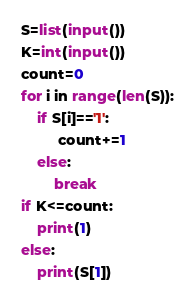Convert code to text. <code><loc_0><loc_0><loc_500><loc_500><_Python_>S=list(input())
K=int(input())
count=0
for i in range(len(S)):
    if S[i]=='1':
         count+=1
    else:
        break
if K<=count:
    print(1)
else:
    print(S[1])</code> 